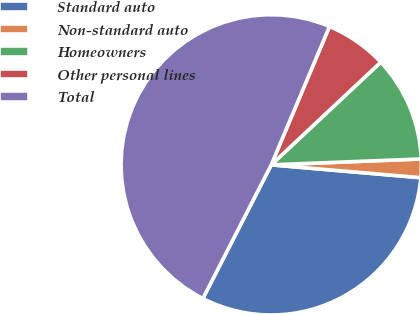Convert chart to OTSL. <chart><loc_0><loc_0><loc_500><loc_500><pie_chart><fcel>Standard auto<fcel>Non-standard auto<fcel>Homeowners<fcel>Other personal lines<fcel>Total<nl><fcel>31.16%<fcel>1.99%<fcel>11.36%<fcel>6.67%<fcel>48.81%<nl></chart> 